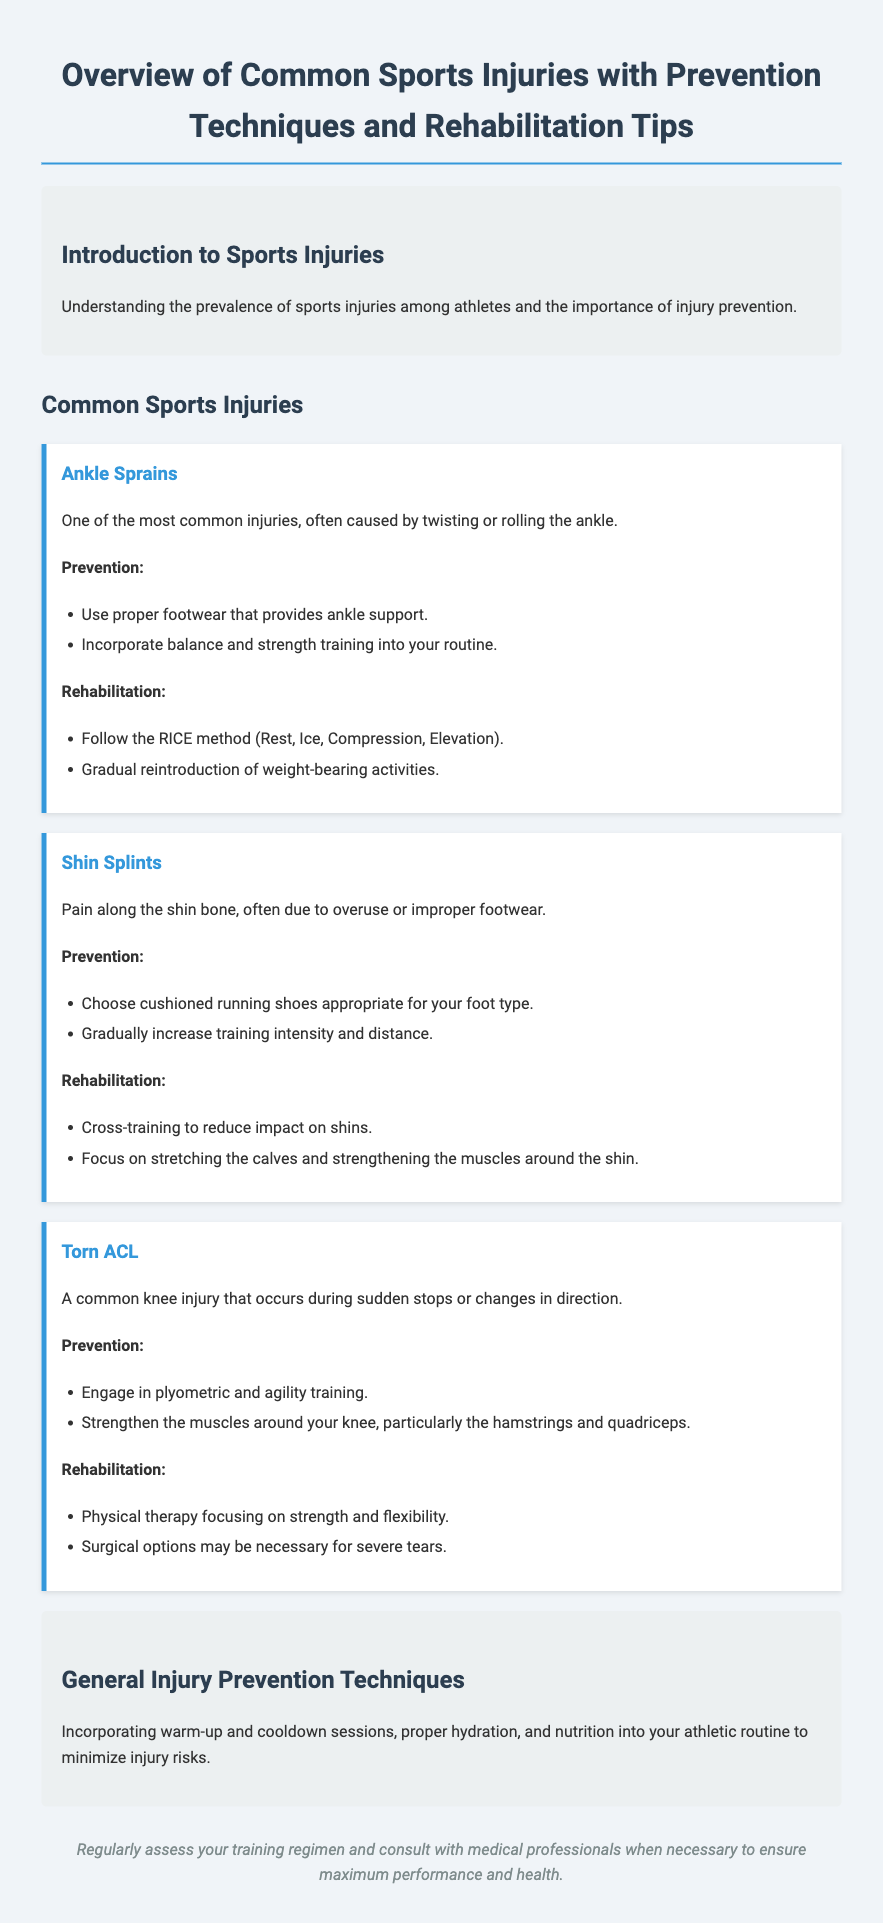What are the most common sports injuries mentioned? The document lists three common sports injuries: Ankle Sprains, Shin Splints, and Torn ACL.
Answer: Ankle Sprains, Shin Splints, Torn ACL What does RICE stand for in rehabilitation? RICE is an acronym for Rest, Ice, Compression, and Elevation, as mentioned for ankle sprains.
Answer: Rest, Ice, Compression, Elevation What technique is suggested for preventing torn ACLs? The document recommends engaging in plyometric and agility training to prevent torn ACLs.
Answer: Plyometric and agility training How should one rehabilitate shin splints? Rehabilitation for shin splints includes cross-training and focusing on calf stretching and muscle strengthening.
Answer: Cross-training, stretching calves, strengthening muscles What is a critical injury prevention technique mentioned? The document emphasizes incorporating warm-up and cooldown sessions as a key injury prevention technique.
Answer: Warm-up and cooldown sessions Which injury is associated with sudden stops? The document states that a torn ACL is a common injury associated with sudden stops or changes in direction.
Answer: Torn ACL List one type of footwear recommended for preventing ankle sprains. The document advises using proper footwear that provides ankle support to prevent ankle sprains.
Answer: Proper footwear with ankle support How can one gradually increase training to prevent shin splints? It is recommended to gradually increase training intensity and distance to help prevent shin splints.
Answer: Gradually increase training intensity and distance 